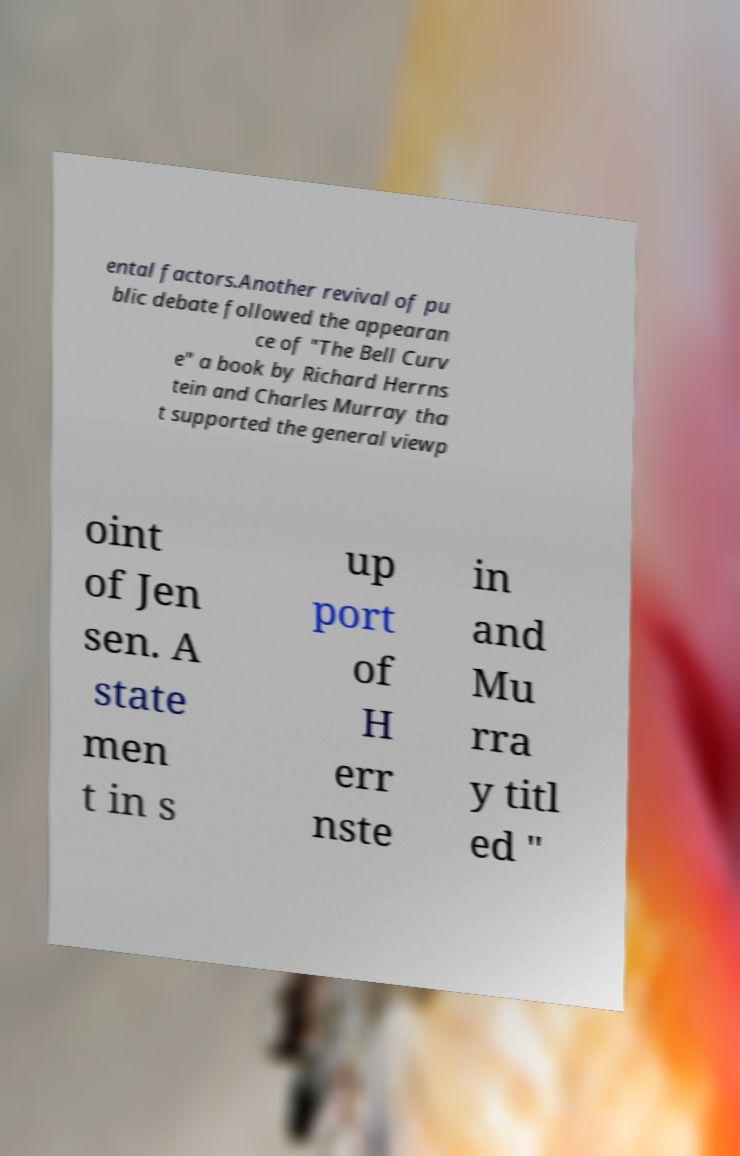Please identify and transcribe the text found in this image. ental factors.Another revival of pu blic debate followed the appearan ce of "The Bell Curv e" a book by Richard Herrns tein and Charles Murray tha t supported the general viewp oint of Jen sen. A state men t in s up port of H err nste in and Mu rra y titl ed " 